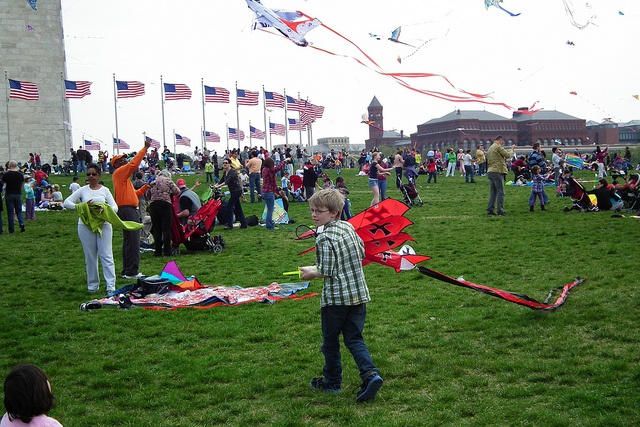Describe the objects in this image and their specific colors. I can see people in gray, black, darkgray, and darkgreen tones, kite in gray, black, darkgreen, and brown tones, people in gray, black, and darkgray tones, people in gray, darkgreen, and lightgray tones, and people in gray, black, pink, darkgray, and lavender tones in this image. 